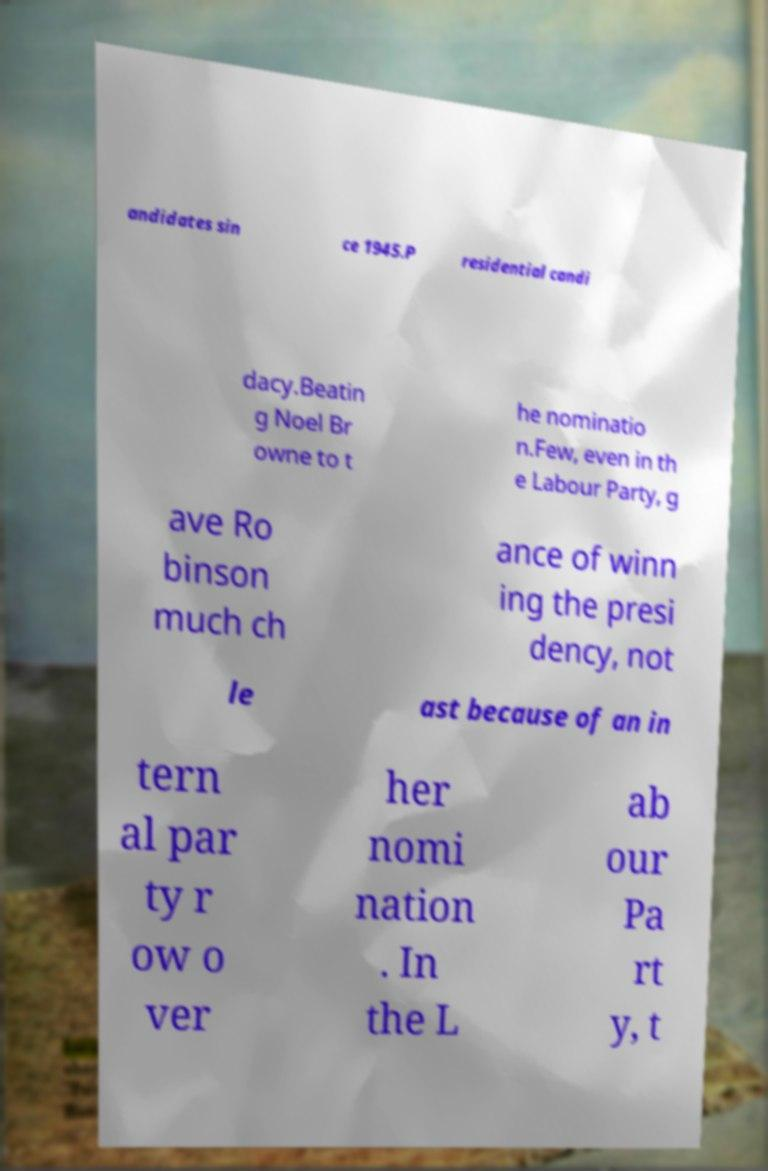Could you extract and type out the text from this image? andidates sin ce 1945.P residential candi dacy.Beatin g Noel Br owne to t he nominatio n.Few, even in th e Labour Party, g ave Ro binson much ch ance of winn ing the presi dency, not le ast because of an in tern al par ty r ow o ver her nomi nation . In the L ab our Pa rt y, t 